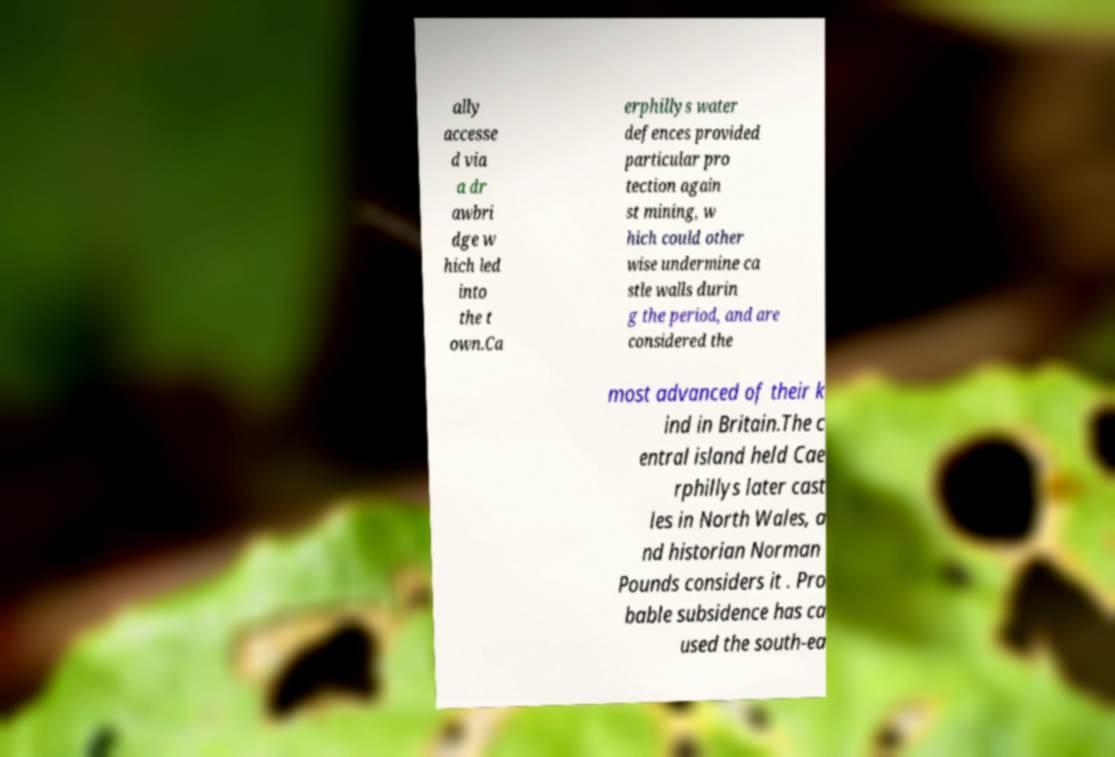I need the written content from this picture converted into text. Can you do that? ally accesse d via a dr awbri dge w hich led into the t own.Ca erphillys water defences provided particular pro tection again st mining, w hich could other wise undermine ca stle walls durin g the period, and are considered the most advanced of their k ind in Britain.The c entral island held Cae rphillys later cast les in North Wales, a nd historian Norman Pounds considers it . Pro bable subsidence has ca used the south-ea 